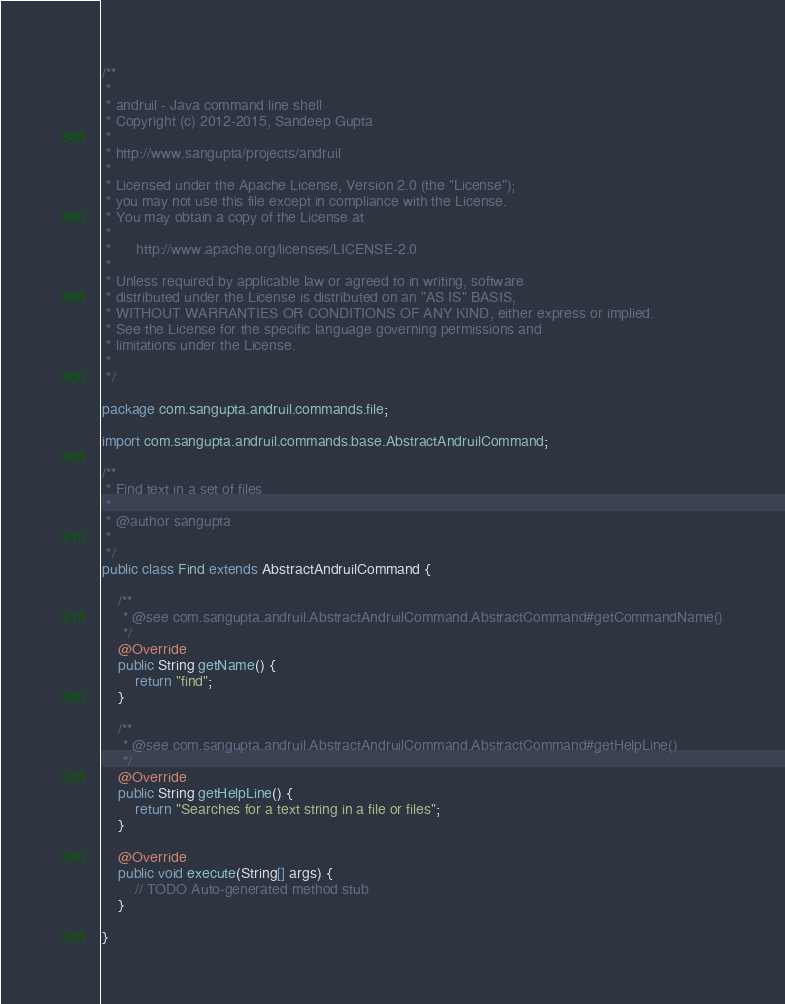Convert code to text. <code><loc_0><loc_0><loc_500><loc_500><_Java_>/**
 *
 * andruil - Java command line shell
 * Copyright (c) 2012-2015, Sandeep Gupta
 * 
 * http://www.sangupta/projects/andruil
 * 
 * Licensed under the Apache License, Version 2.0 (the "License");
 * you may not use this file except in compliance with the License.
 * You may obtain a copy of the License at
 * 
 * 		http://www.apache.org/licenses/LICENSE-2.0
 * 
 * Unless required by applicable law or agreed to in writing, software
 * distributed under the License is distributed on an "AS IS" BASIS,
 * WITHOUT WARRANTIES OR CONDITIONS OF ANY KIND, either express or implied.
 * See the License for the specific language governing permissions and
 * limitations under the License.
 * 
 */

package com.sangupta.andruil.commands.file;

import com.sangupta.andruil.commands.base.AbstractAndruilCommand;

/**
 * Find text in a set of files
 * 
 * @author sangupta
 *
 */
public class Find extends AbstractAndruilCommand {

	/**
	 * @see com.sangupta.andruil.AbstractAndruilCommand.AbstractCommand#getCommandName()
	 */
	@Override
	public String getName() {
		return "find";
	}

	/**
	 * @see com.sangupta.andruil.AbstractAndruilCommand.AbstractCommand#getHelpLine()
	 */
	@Override
	public String getHelpLine() {
		return "Searches for a text string in a file or files";
	}

	@Override
	public void execute(String[] args) {
		// TODO Auto-generated method stub
	}

}</code> 